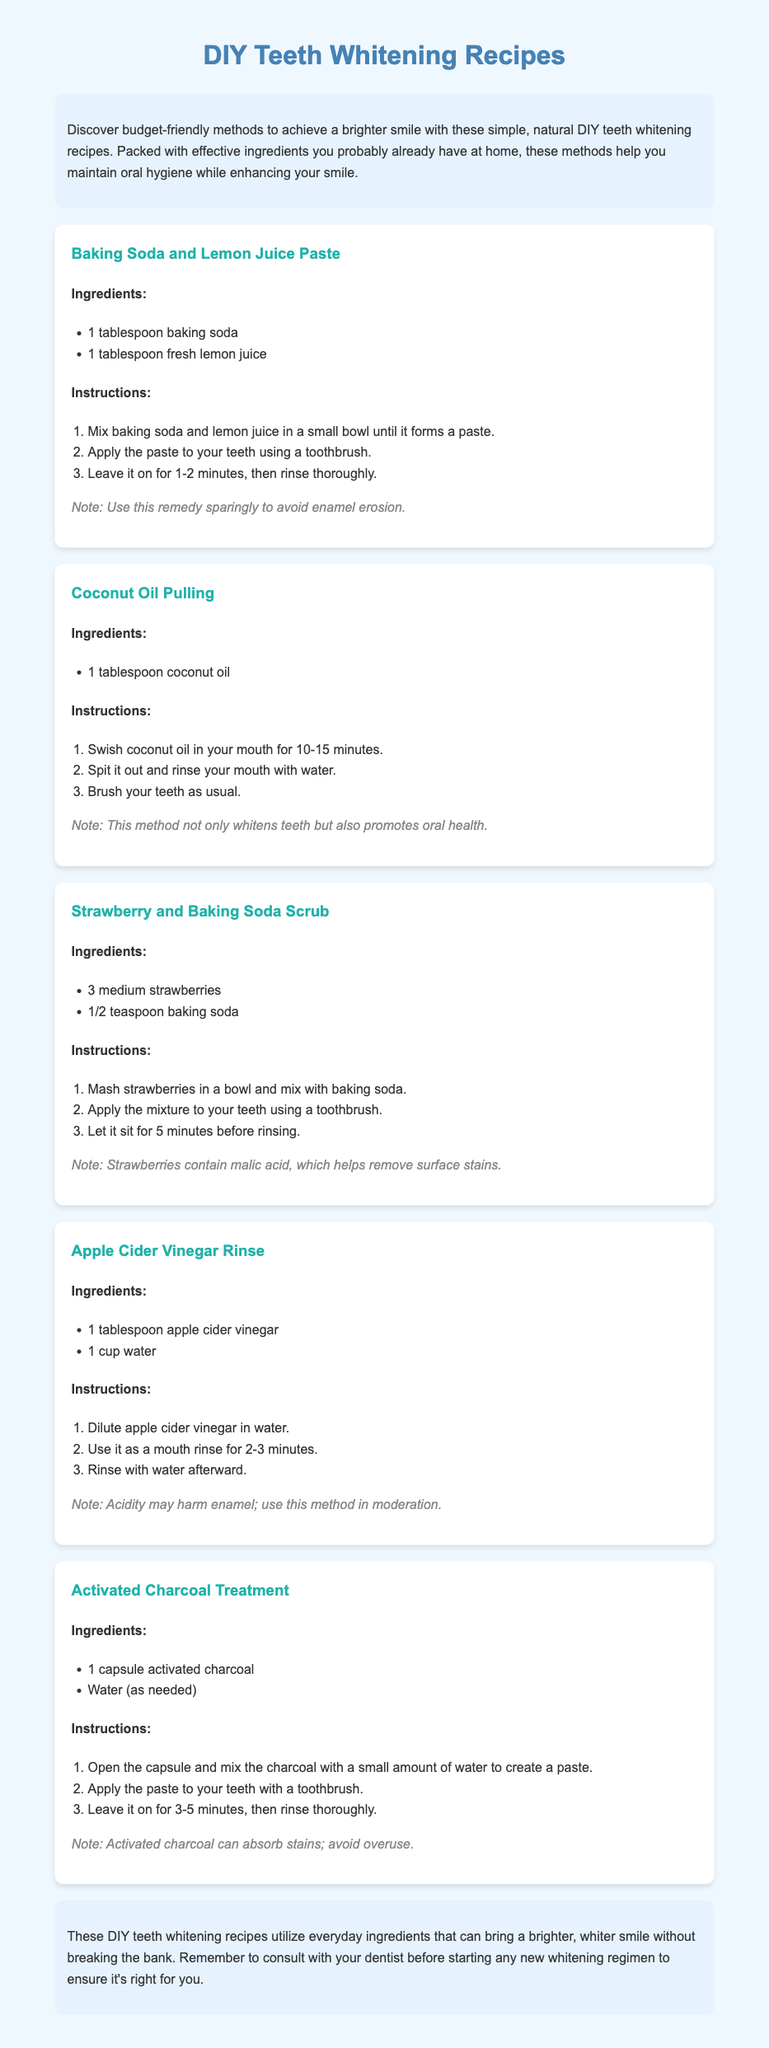What is the first DIY teeth whitening recipe listed? The first recipe mentioned in the document is for a Baking Soda and Lemon Juice Paste.
Answer: Baking Soda and Lemon Juice Paste How many strawberries are needed for the Strawberry and Baking Soda Scrub? The recipe indicates that 3 medium strawberries are required.
Answer: 3 medium strawberries What is used as an ingredient in the Coconut Oil Pulling method? The method requires 1 tablespoon of coconut oil as an ingredient.
Answer: 1 tablespoon coconut oil What is the note regarding the Baking Soda and Lemon Juice Paste? The note advises to use this remedy sparingly to avoid enamel erosion.
Answer: Use this remedy sparingly to avoid enamel erosion How long should apple cider vinegar rinse be used? The instructions state to use it for 2-3 minutes as a mouth rinse.
Answer: 2-3 minutes What does activated charcoal do in teeth whitening? Activated charcoal is noted for its ability to absorb stains.
Answer: Absorb stains What overall approach do these recipes promote? The recipes promote budget-friendly methods for achieving a brighter smile.
Answer: Budget-friendly methods What is a precaution mentioned for the Apple Cider Vinegar Rinse? It is noted that the acidity may harm enamel, hence moderation is recommended.
Answer: Acidity may harm enamel; moderation is advised 